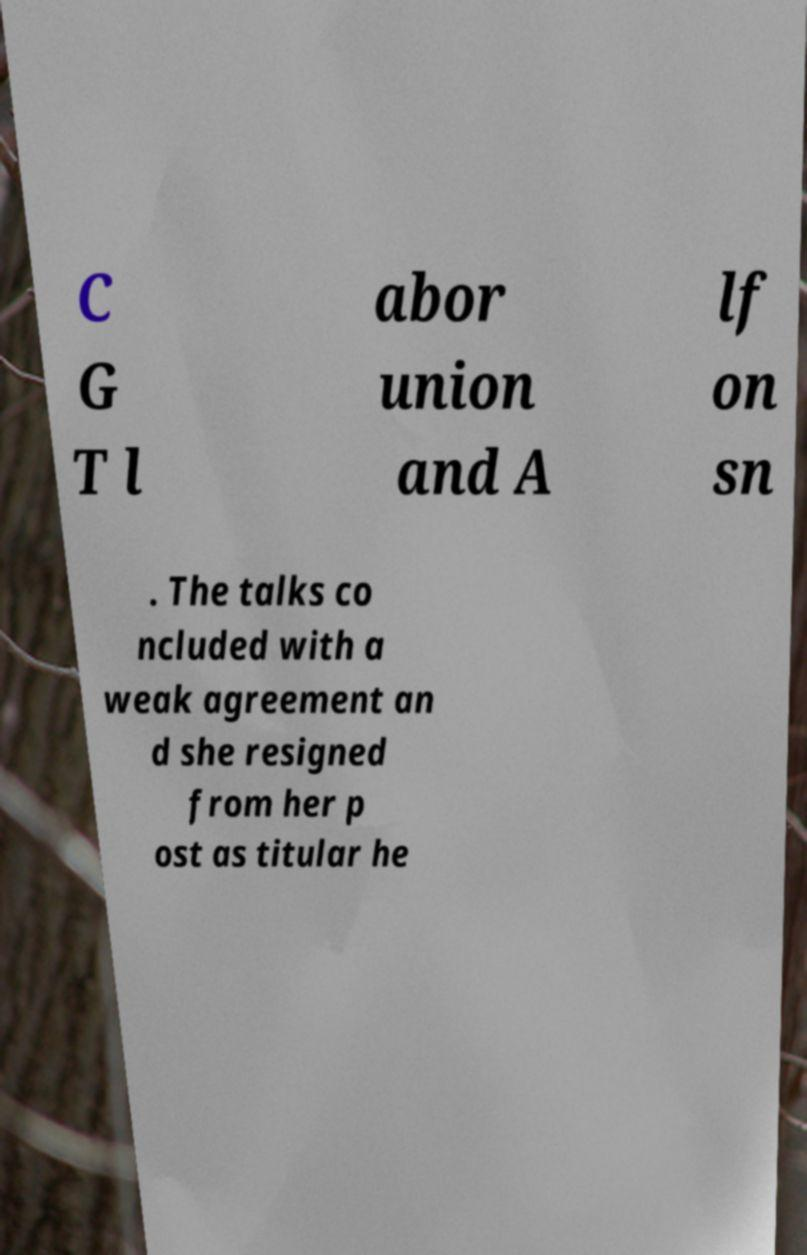For documentation purposes, I need the text within this image transcribed. Could you provide that? C G T l abor union and A lf on sn . The talks co ncluded with a weak agreement an d she resigned from her p ost as titular he 